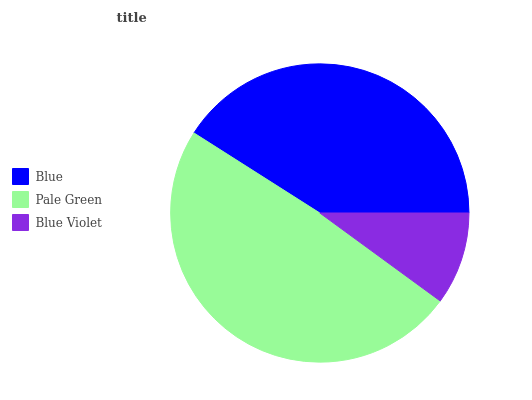Is Blue Violet the minimum?
Answer yes or no. Yes. Is Pale Green the maximum?
Answer yes or no. Yes. Is Pale Green the minimum?
Answer yes or no. No. Is Blue Violet the maximum?
Answer yes or no. No. Is Pale Green greater than Blue Violet?
Answer yes or no. Yes. Is Blue Violet less than Pale Green?
Answer yes or no. Yes. Is Blue Violet greater than Pale Green?
Answer yes or no. No. Is Pale Green less than Blue Violet?
Answer yes or no. No. Is Blue the high median?
Answer yes or no. Yes. Is Blue the low median?
Answer yes or no. Yes. Is Blue Violet the high median?
Answer yes or no. No. Is Blue Violet the low median?
Answer yes or no. No. 